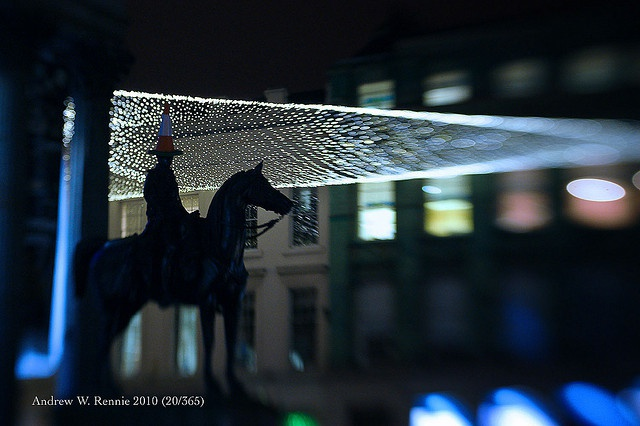Describe the objects in this image and their specific colors. I can see horse in black, navy, gray, and darkgray tones and people in black, gray, navy, and lightgray tones in this image. 